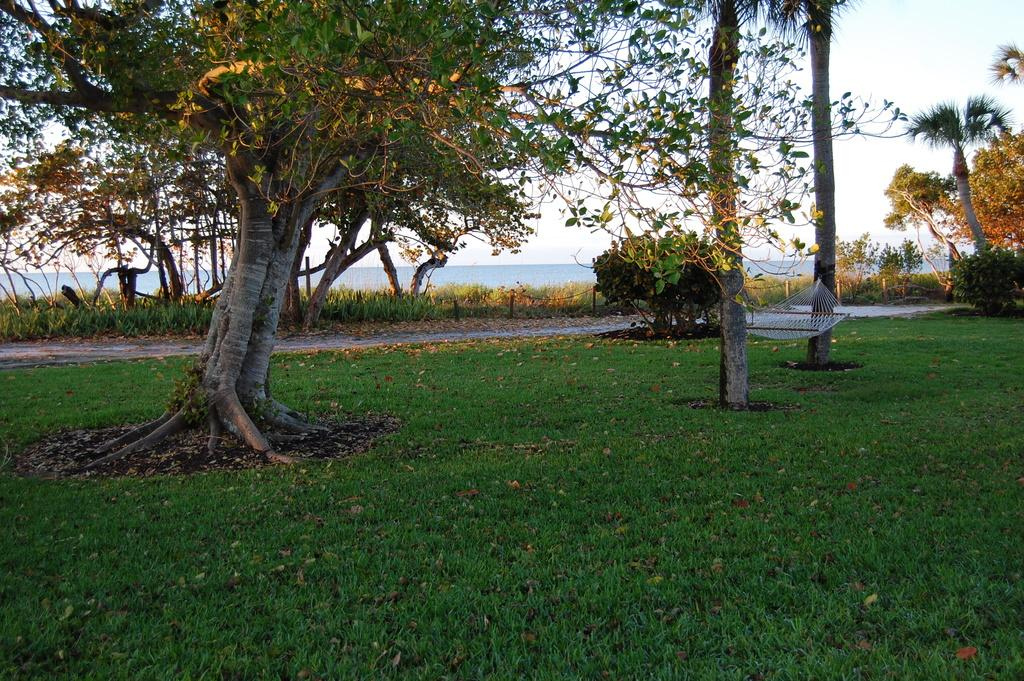What type of terrain is at the bottom of the image? There is a grassy land at the bottom of the image. What can be seen growing in the image? There are many trees and plants in the image. What large body of water is present in the image? There is an ocean at the center of the image. How many cherries are hanging from the trees in the image? There is no mention of cherries in the image; it features grassy land, trees, plants, and an ocean. What type of hole can be seen in the harmony of the image? There is no hole or harmony mentioned in the image; it is a landscape featuring grassy land, trees, plants, and an ocean. 